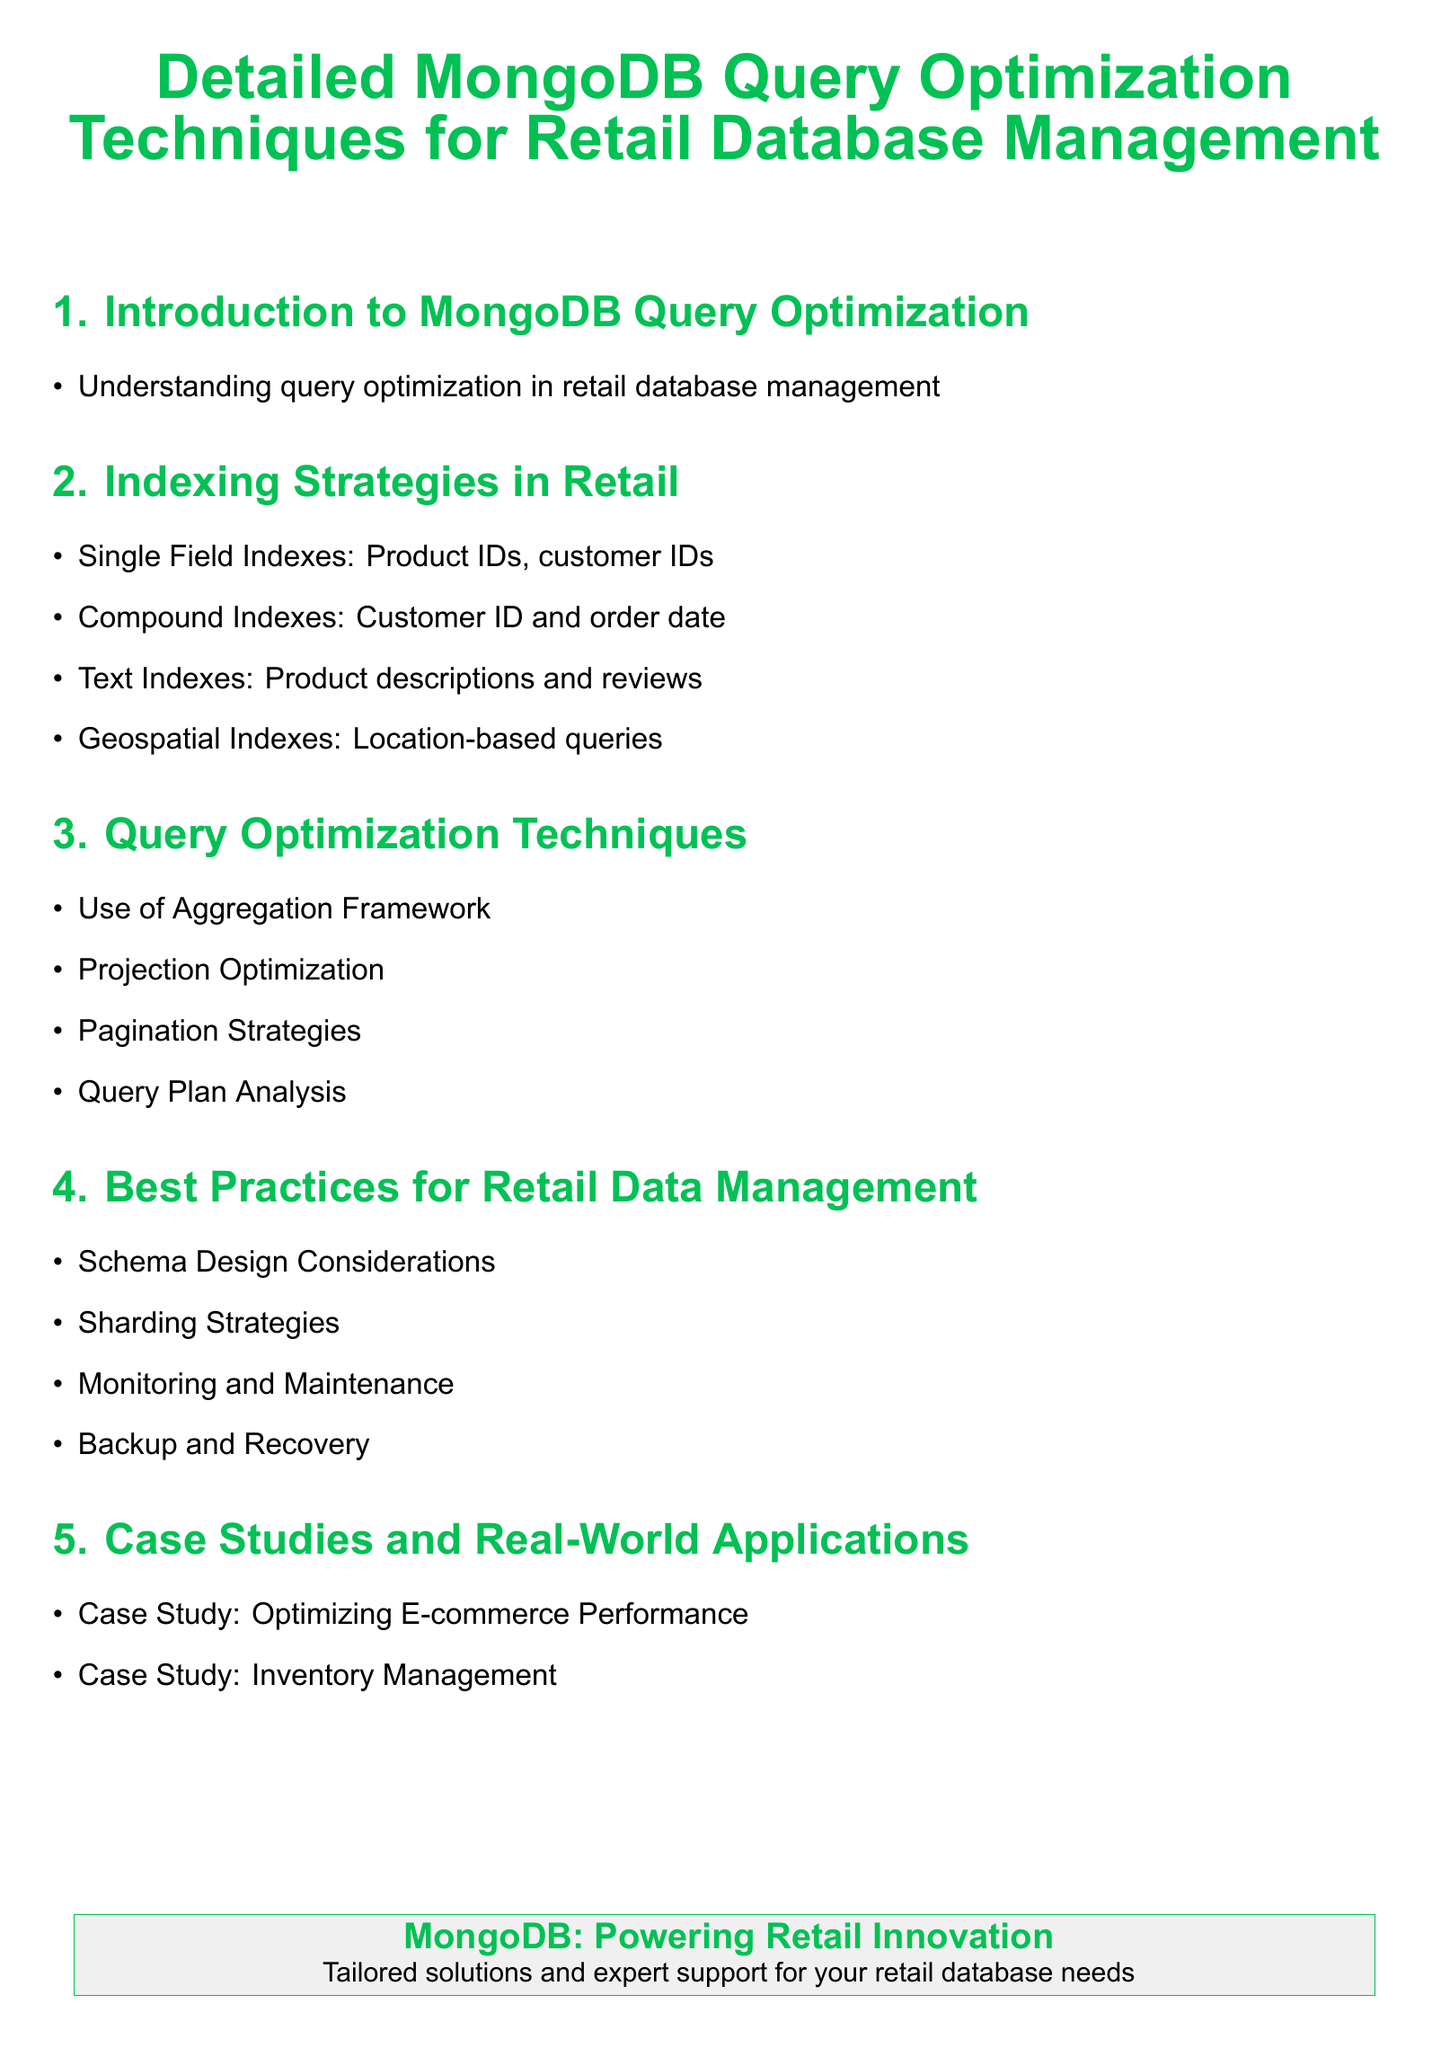What is the title of the document? The title is prominently displayed at the top of the document, stating the focus on query optimization techniques specifically for retail database management.
Answer: Detailed MongoDB Query Optimization Techniques for Retail Database Management What is one example of a single field index? The document lists examples of single field indexes under the indexing strategies section, specifically mentioning product IDs and customer IDs.
Answer: Product IDs What are compound indexes used for? The document specifies that compound indexes are used for combinations of fields, like customer ID and order date.
Answer: Customer ID and order date What optimization technique involves analyzing query plans? The document highlights the importance of reviewing query execution via various techniques, including query plan analysis.
Answer: Query Plan Analysis Which case study focuses on e-commerce performance? One of the case studies mentioned in the document is dedicated to examining methods to enhance performance in an e-commerce context.
Answer: Optimizing E-commerce Performance What is a key consideration for retail data management schema design? The document emphasizes various considerations under best practices, including schema design as a foundational element.
Answer: Schema Design Considerations What type of index is used for location-based queries? The document directly addresses specific index types, identifying geospatial indexes for queries involving locations.
Answer: Geospatial Indexes What aspect of query optimization involves controlling the amount of data returned? The technique is described in the context of optimizing how queries project data back to the user.
Answer: Projection Optimization What is the purpose of sharding strategies? The best practices section summarizes that sharding helps in effectively managing data across multiple servers.
Answer: Sharding Strategies 